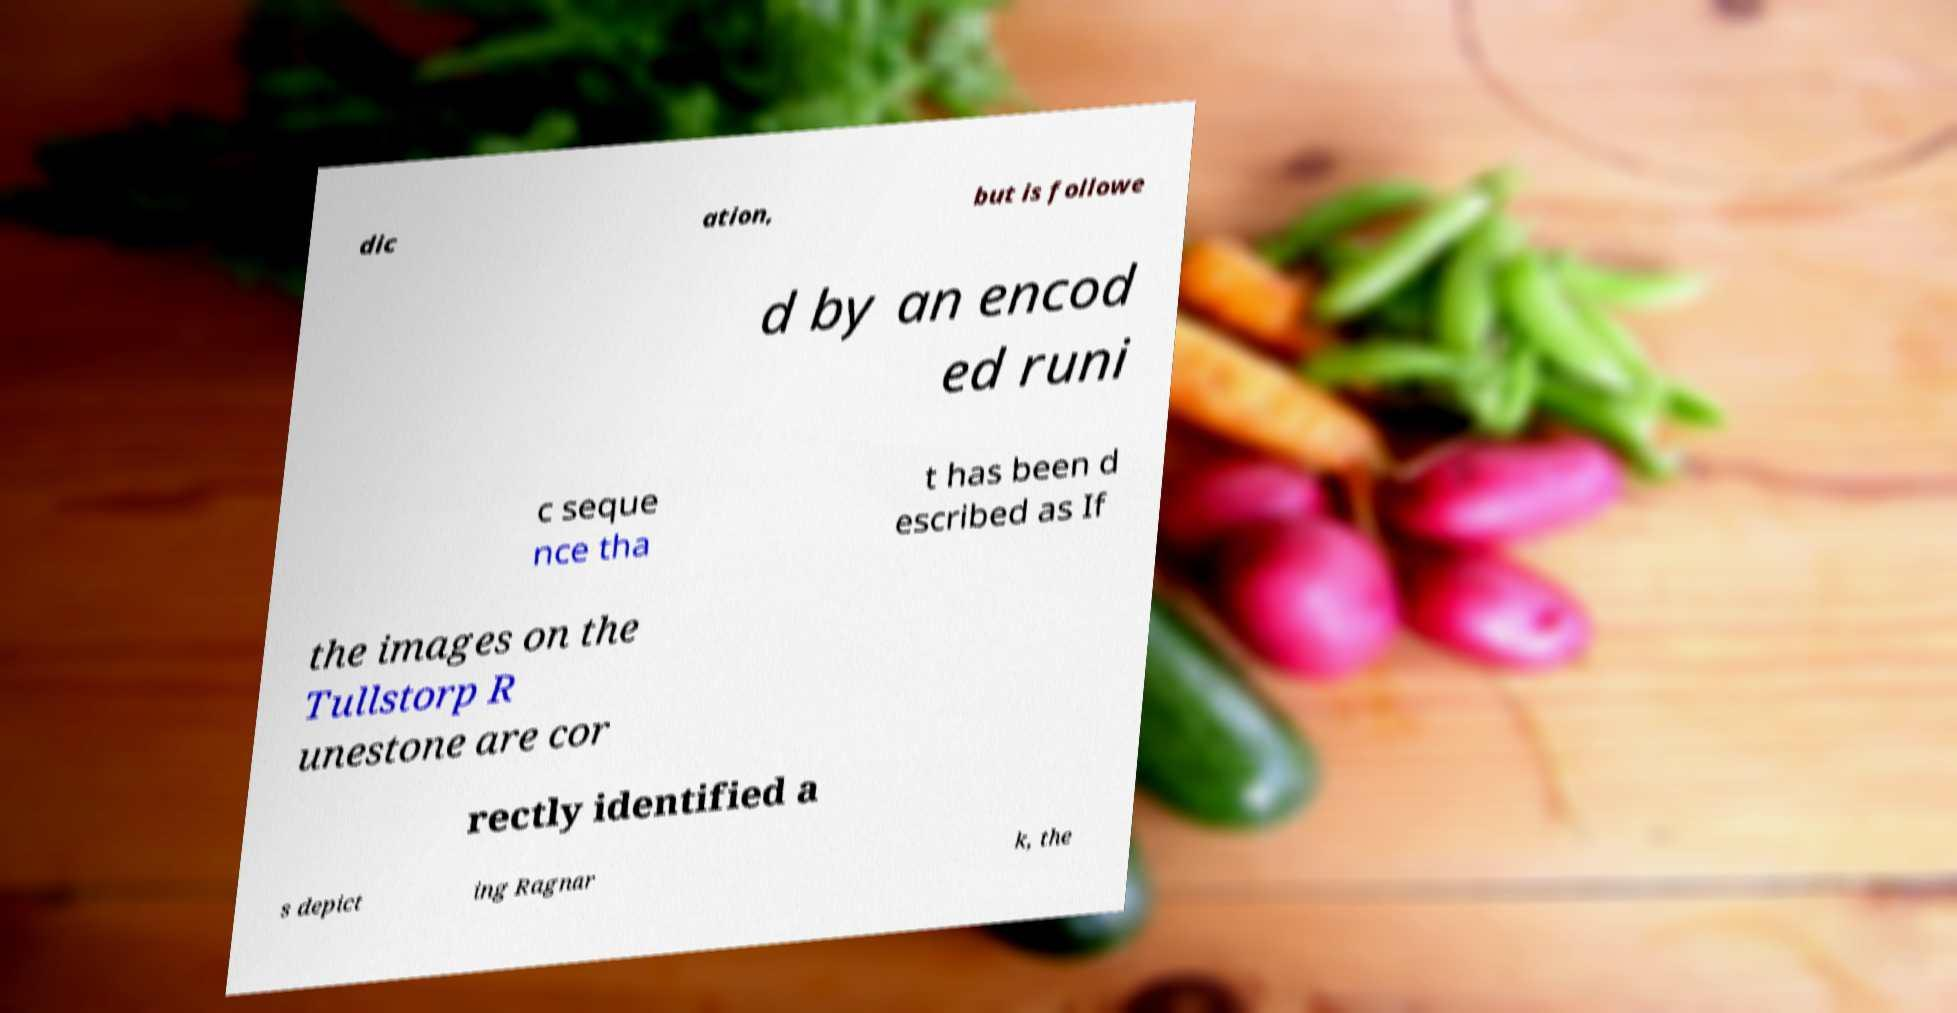For documentation purposes, I need the text within this image transcribed. Could you provide that? dic ation, but is followe d by an encod ed runi c seque nce tha t has been d escribed as If the images on the Tullstorp R unestone are cor rectly identified a s depict ing Ragnar k, the 